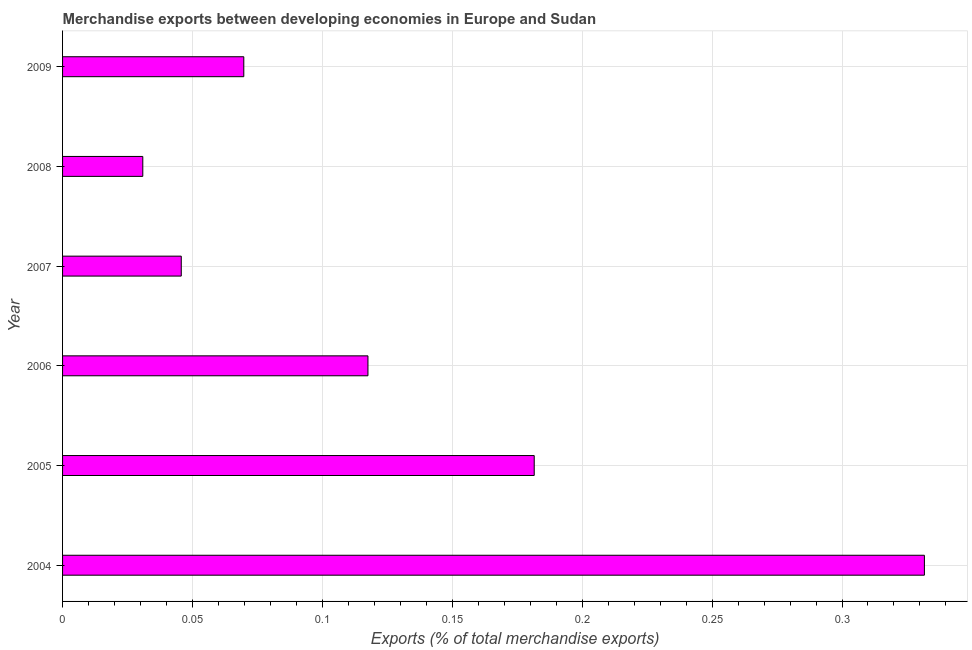Does the graph contain grids?
Your answer should be compact. Yes. What is the title of the graph?
Keep it short and to the point. Merchandise exports between developing economies in Europe and Sudan. What is the label or title of the X-axis?
Your answer should be compact. Exports (% of total merchandise exports). What is the merchandise exports in 2005?
Your answer should be very brief. 0.18. Across all years, what is the maximum merchandise exports?
Offer a very short reply. 0.33. Across all years, what is the minimum merchandise exports?
Provide a short and direct response. 0.03. What is the sum of the merchandise exports?
Provide a short and direct response. 0.78. What is the difference between the merchandise exports in 2004 and 2007?
Give a very brief answer. 0.29. What is the average merchandise exports per year?
Your answer should be very brief. 0.13. What is the median merchandise exports?
Keep it short and to the point. 0.09. In how many years, is the merchandise exports greater than 0.13 %?
Make the answer very short. 2. What is the ratio of the merchandise exports in 2005 to that in 2007?
Your answer should be very brief. 3.97. Is the merchandise exports in 2004 less than that in 2009?
Your answer should be compact. No. Is the sum of the merchandise exports in 2004 and 2008 greater than the maximum merchandise exports across all years?
Your response must be concise. Yes. What is the difference between the highest and the lowest merchandise exports?
Provide a short and direct response. 0.3. How many bars are there?
Ensure brevity in your answer.  6. What is the difference between two consecutive major ticks on the X-axis?
Your answer should be very brief. 0.05. What is the Exports (% of total merchandise exports) of 2004?
Your response must be concise. 0.33. What is the Exports (% of total merchandise exports) of 2005?
Provide a short and direct response. 0.18. What is the Exports (% of total merchandise exports) of 2006?
Offer a very short reply. 0.12. What is the Exports (% of total merchandise exports) of 2007?
Provide a short and direct response. 0.05. What is the Exports (% of total merchandise exports) in 2008?
Offer a terse response. 0.03. What is the Exports (% of total merchandise exports) in 2009?
Your answer should be very brief. 0.07. What is the difference between the Exports (% of total merchandise exports) in 2004 and 2005?
Your answer should be very brief. 0.15. What is the difference between the Exports (% of total merchandise exports) in 2004 and 2006?
Ensure brevity in your answer.  0.21. What is the difference between the Exports (% of total merchandise exports) in 2004 and 2007?
Keep it short and to the point. 0.29. What is the difference between the Exports (% of total merchandise exports) in 2004 and 2008?
Offer a very short reply. 0.3. What is the difference between the Exports (% of total merchandise exports) in 2004 and 2009?
Make the answer very short. 0.26. What is the difference between the Exports (% of total merchandise exports) in 2005 and 2006?
Offer a very short reply. 0.06. What is the difference between the Exports (% of total merchandise exports) in 2005 and 2007?
Give a very brief answer. 0.14. What is the difference between the Exports (% of total merchandise exports) in 2005 and 2008?
Offer a terse response. 0.15. What is the difference between the Exports (% of total merchandise exports) in 2005 and 2009?
Give a very brief answer. 0.11. What is the difference between the Exports (% of total merchandise exports) in 2006 and 2007?
Provide a succinct answer. 0.07. What is the difference between the Exports (% of total merchandise exports) in 2006 and 2008?
Keep it short and to the point. 0.09. What is the difference between the Exports (% of total merchandise exports) in 2006 and 2009?
Provide a short and direct response. 0.05. What is the difference between the Exports (% of total merchandise exports) in 2007 and 2008?
Keep it short and to the point. 0.01. What is the difference between the Exports (% of total merchandise exports) in 2007 and 2009?
Your answer should be very brief. -0.02. What is the difference between the Exports (% of total merchandise exports) in 2008 and 2009?
Offer a very short reply. -0.04. What is the ratio of the Exports (% of total merchandise exports) in 2004 to that in 2005?
Keep it short and to the point. 1.83. What is the ratio of the Exports (% of total merchandise exports) in 2004 to that in 2006?
Offer a very short reply. 2.82. What is the ratio of the Exports (% of total merchandise exports) in 2004 to that in 2007?
Offer a very short reply. 7.26. What is the ratio of the Exports (% of total merchandise exports) in 2004 to that in 2008?
Offer a terse response. 10.74. What is the ratio of the Exports (% of total merchandise exports) in 2004 to that in 2009?
Offer a very short reply. 4.75. What is the ratio of the Exports (% of total merchandise exports) in 2005 to that in 2006?
Provide a short and direct response. 1.54. What is the ratio of the Exports (% of total merchandise exports) in 2005 to that in 2007?
Your answer should be very brief. 3.97. What is the ratio of the Exports (% of total merchandise exports) in 2005 to that in 2008?
Provide a succinct answer. 5.88. What is the ratio of the Exports (% of total merchandise exports) in 2005 to that in 2009?
Keep it short and to the point. 2.6. What is the ratio of the Exports (% of total merchandise exports) in 2006 to that in 2007?
Ensure brevity in your answer.  2.57. What is the ratio of the Exports (% of total merchandise exports) in 2006 to that in 2008?
Offer a terse response. 3.81. What is the ratio of the Exports (% of total merchandise exports) in 2006 to that in 2009?
Offer a very short reply. 1.69. What is the ratio of the Exports (% of total merchandise exports) in 2007 to that in 2008?
Provide a short and direct response. 1.48. What is the ratio of the Exports (% of total merchandise exports) in 2007 to that in 2009?
Your answer should be compact. 0.66. What is the ratio of the Exports (% of total merchandise exports) in 2008 to that in 2009?
Provide a short and direct response. 0.44. 